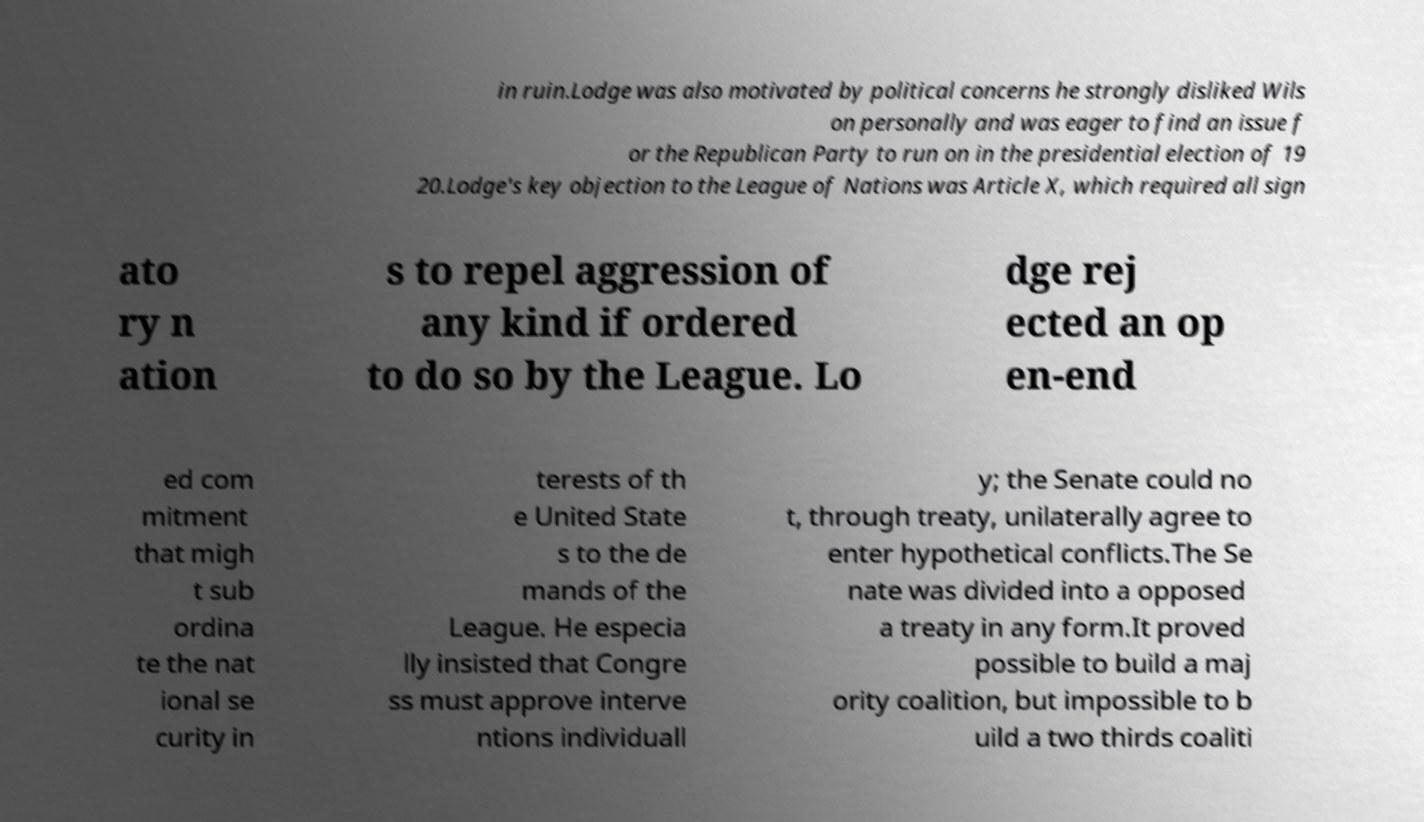Please read and relay the text visible in this image. What does it say? in ruin.Lodge was also motivated by political concerns he strongly disliked Wils on personally and was eager to find an issue f or the Republican Party to run on in the presidential election of 19 20.Lodge's key objection to the League of Nations was Article X, which required all sign ato ry n ation s to repel aggression of any kind if ordered to do so by the League. Lo dge rej ected an op en-end ed com mitment that migh t sub ordina te the nat ional se curity in terests of th e United State s to the de mands of the League. He especia lly insisted that Congre ss must approve interve ntions individuall y; the Senate could no t, through treaty, unilaterally agree to enter hypothetical conflicts.The Se nate was divided into a opposed a treaty in any form.It proved possible to build a maj ority coalition, but impossible to b uild a two thirds coaliti 